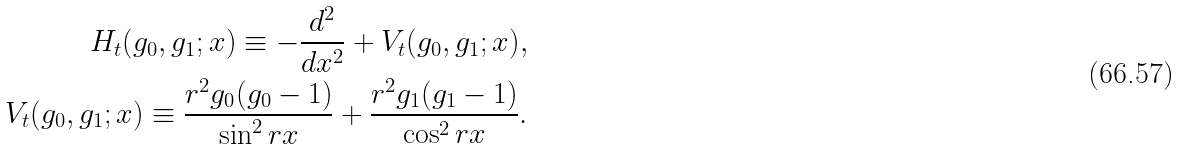Convert formula to latex. <formula><loc_0><loc_0><loc_500><loc_500>H _ { t } ( g _ { 0 } , g _ { 1 } ; x ) \equiv - \frac { d ^ { 2 } } { d x ^ { 2 } } + V _ { t } ( g _ { 0 } , g _ { 1 } ; x ) , \\ V _ { t } ( g _ { 0 } , g _ { 1 } ; x ) \equiv \frac { r ^ { 2 } g _ { 0 } ( g _ { 0 } - 1 ) } { \sin ^ { 2 } r x } + \frac { r ^ { 2 } g _ { 1 } ( g _ { 1 } - 1 ) } { \cos ^ { 2 } r x } .</formula> 